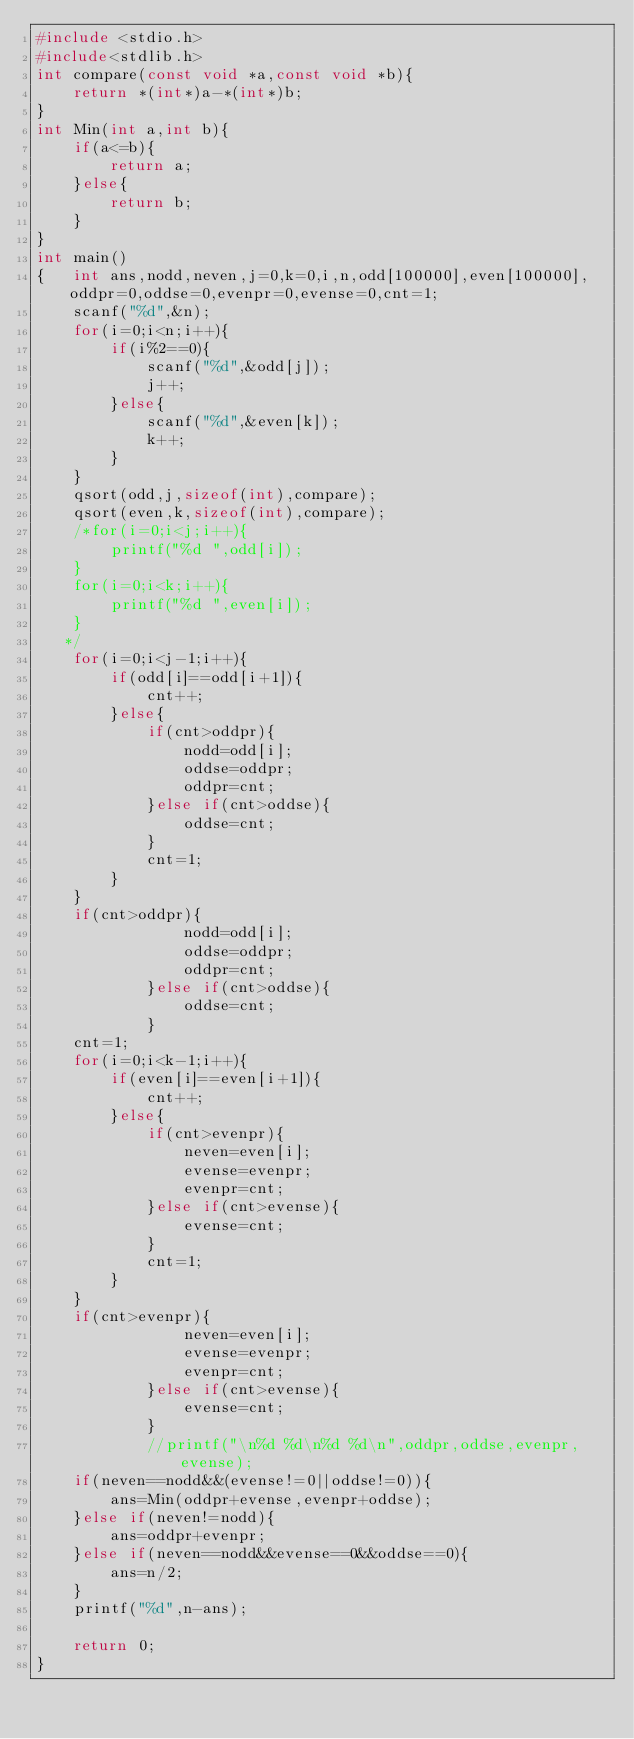Convert code to text. <code><loc_0><loc_0><loc_500><loc_500><_C_>#include <stdio.h>
#include<stdlib.h>
int compare(const void *a,const void *b){
    return *(int*)a-*(int*)b;
}
int Min(int a,int b){
    if(a<=b){
        return a;
    }else{
        return b;
    }
}
int main()
{   int ans,nodd,neven,j=0,k=0,i,n,odd[100000],even[100000],oddpr=0,oddse=0,evenpr=0,evense=0,cnt=1;
    scanf("%d",&n);
    for(i=0;i<n;i++){
        if(i%2==0){
            scanf("%d",&odd[j]);
            j++;
        }else{
            scanf("%d",&even[k]);
            k++;
        }
    }
    qsort(odd,j,sizeof(int),compare);
    qsort(even,k,sizeof(int),compare);
    /*for(i=0;i<j;i++){
        printf("%d ",odd[i]);
    }
    for(i=0;i<k;i++){
        printf("%d ",even[i]);
    }
   */
    for(i=0;i<j-1;i++){
        if(odd[i]==odd[i+1]){
            cnt++;
        }else{
            if(cnt>oddpr){
                nodd=odd[i];
                oddse=oddpr;
                oddpr=cnt;
            }else if(cnt>oddse){
                oddse=cnt;
            }
            cnt=1;
        }
    }
    if(cnt>oddpr){
                nodd=odd[i];
                oddse=oddpr;
                oddpr=cnt;
            }else if(cnt>oddse){
                oddse=cnt;
            }
    cnt=1;
    for(i=0;i<k-1;i++){
        if(even[i]==even[i+1]){
            cnt++;
        }else{
            if(cnt>evenpr){
                neven=even[i];
                evense=evenpr;
                evenpr=cnt;
            }else if(cnt>evense){
                evense=cnt;
            }
            cnt=1;
        }
    }
    if(cnt>evenpr){
                neven=even[i];
                evense=evenpr;
                evenpr=cnt;
            }else if(cnt>evense){
                evense=cnt;
            }
            //printf("\n%d %d\n%d %d\n",oddpr,oddse,evenpr,evense);
    if(neven==nodd&&(evense!=0||oddse!=0)){
        ans=Min(oddpr+evense,evenpr+oddse);
    }else if(neven!=nodd){
        ans=oddpr+evenpr;
    }else if(neven==nodd&&evense==0&&oddse==0){
        ans=n/2;
    }
    printf("%d",n-ans);
    
    return 0;
}
</code> 